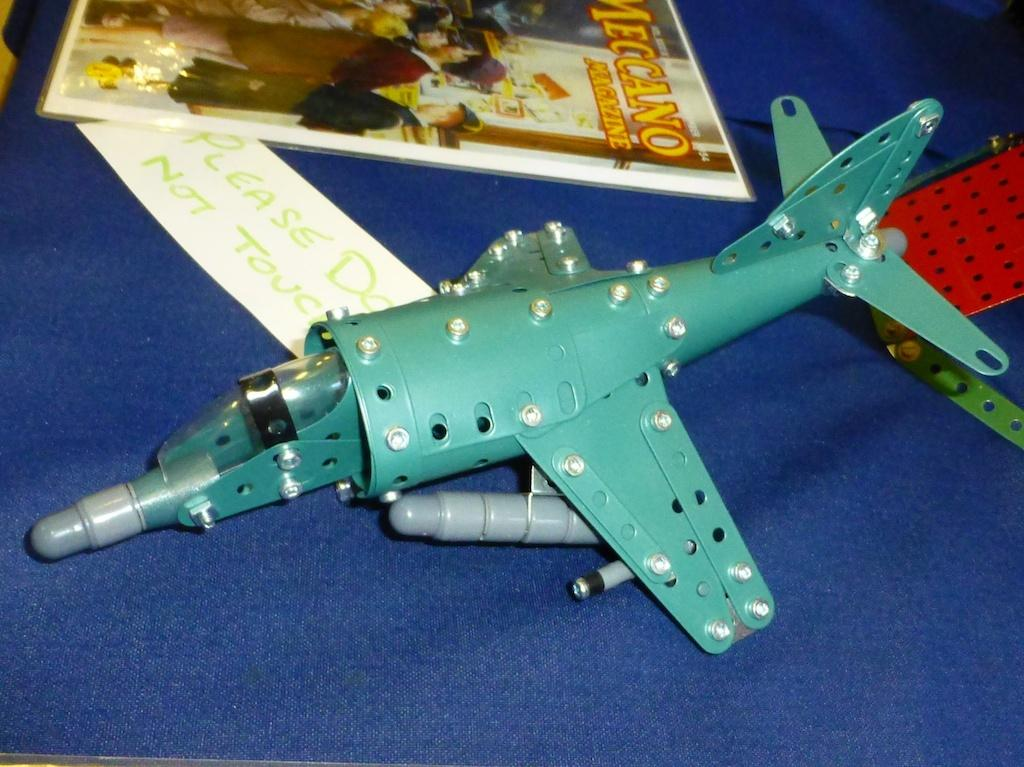<image>
Describe the image concisely. A blue meccano plane sits on a table next to a Meccano magazine 